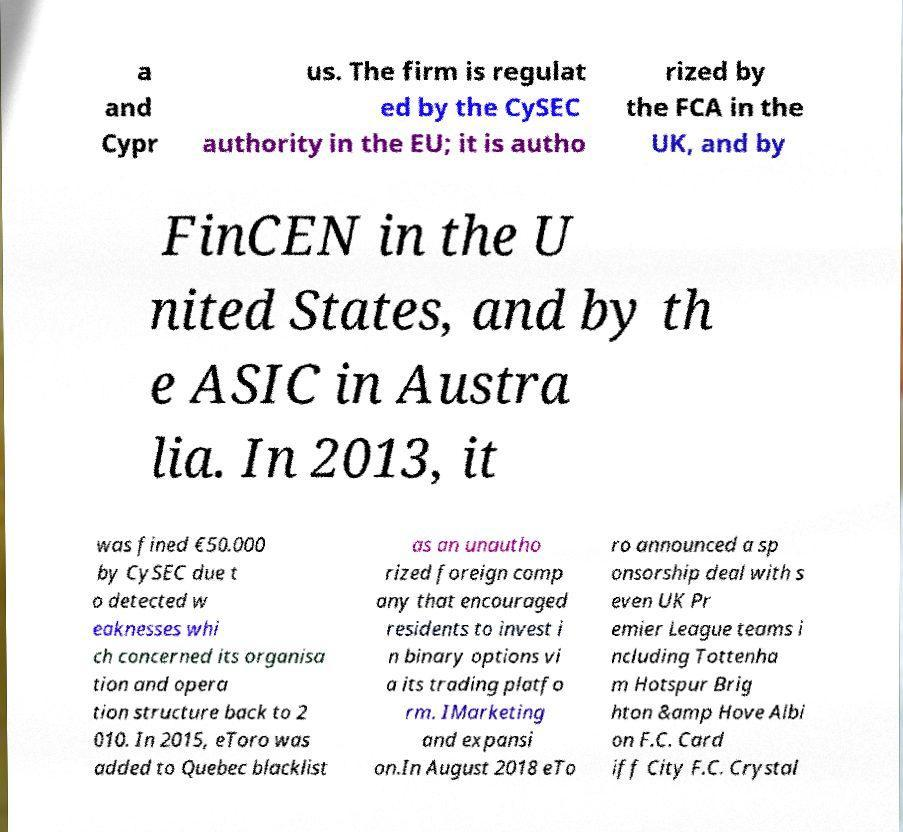I need the written content from this picture converted into text. Can you do that? a and Cypr us. The firm is regulat ed by the CySEC authority in the EU; it is autho rized by the FCA in the UK, and by FinCEN in the U nited States, and by th e ASIC in Austra lia. In 2013, it was fined €50.000 by CySEC due t o detected w eaknesses whi ch concerned its organisa tion and opera tion structure back to 2 010. In 2015, eToro was added to Quebec blacklist as an unautho rized foreign comp any that encouraged residents to invest i n binary options vi a its trading platfo rm. IMarketing and expansi on.In August 2018 eTo ro announced a sp onsorship deal with s even UK Pr emier League teams i ncluding Tottenha m Hotspur Brig hton &amp Hove Albi on F.C. Card iff City F.C. Crystal 